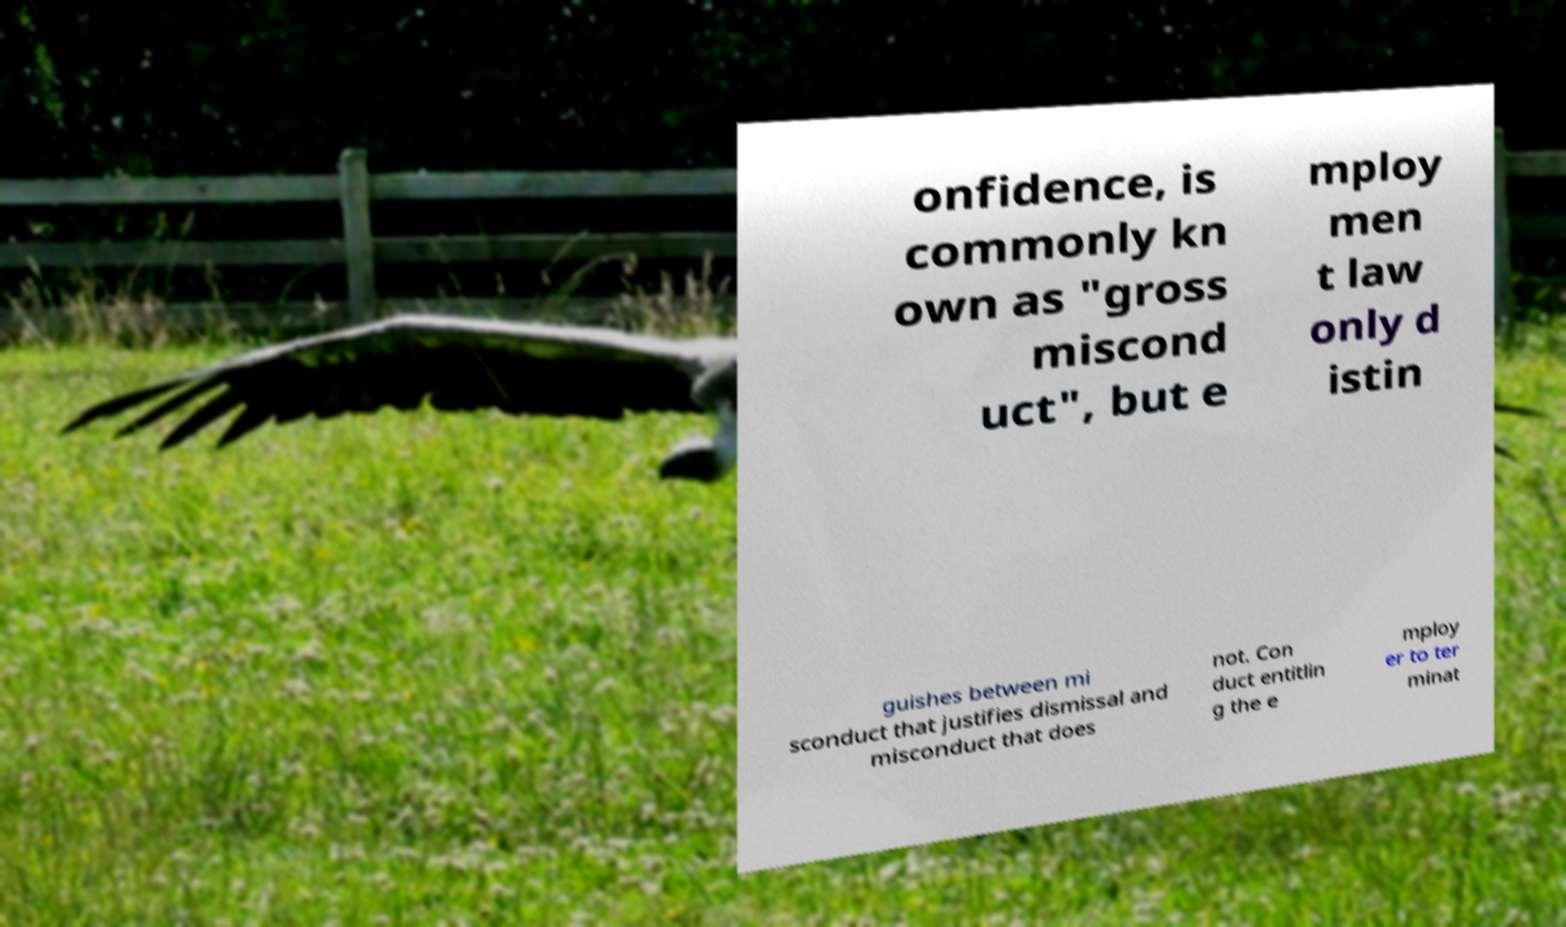Please identify and transcribe the text found in this image. onfidence, is commonly kn own as "gross miscond uct", but e mploy men t law only d istin guishes between mi sconduct that justifies dismissal and misconduct that does not. Con duct entitlin g the e mploy er to ter minat 